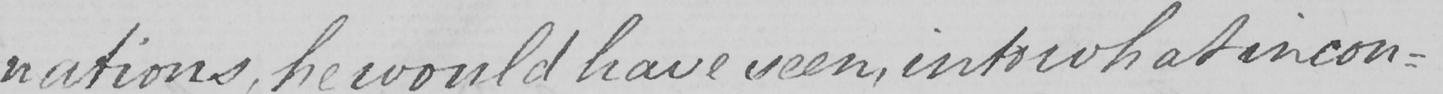Can you read and transcribe this handwriting? nations , he would have seen , into what incon- 